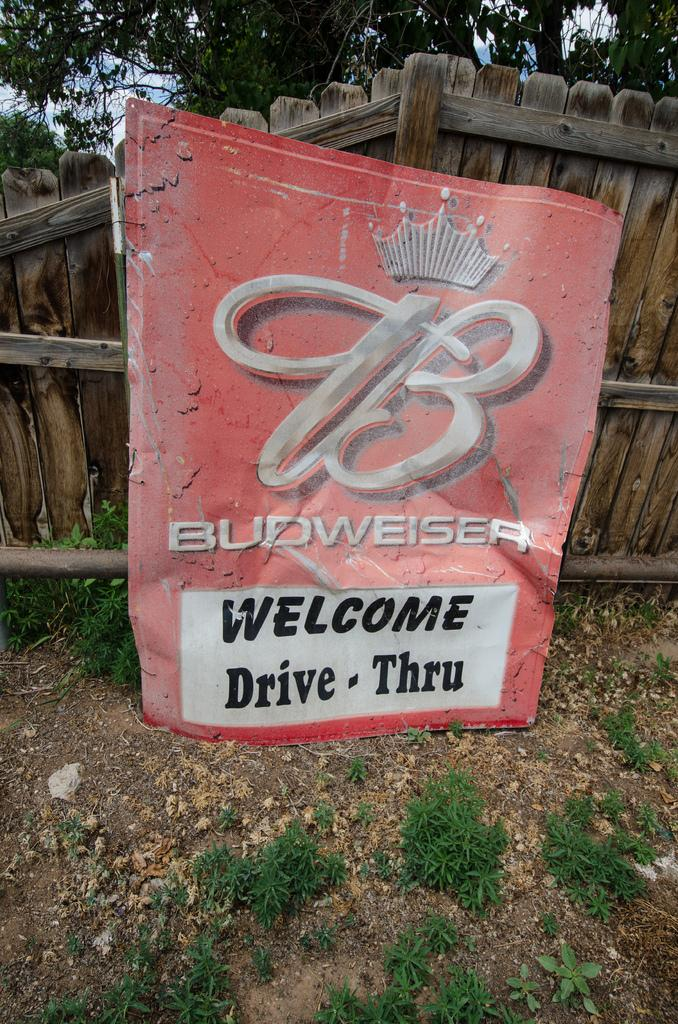What is the color of the board in the image? The board in the image is red. What type of door can be seen in the background of the image? There is a wooden door in the background of the image. What color are the trees in the background of the image? The trees in the background of the image have a green color. What colors are present in the sky in the image? The sky has a white and blue color in the image. How many apples are hanging from the red board in the image? There are no apples present in the image; it only features a red board. Is the wooden door in the image hot to the touch? The wooden door's temperature cannot be determined from the image, as it is a two-dimensional representation and does not convey temperature information. 